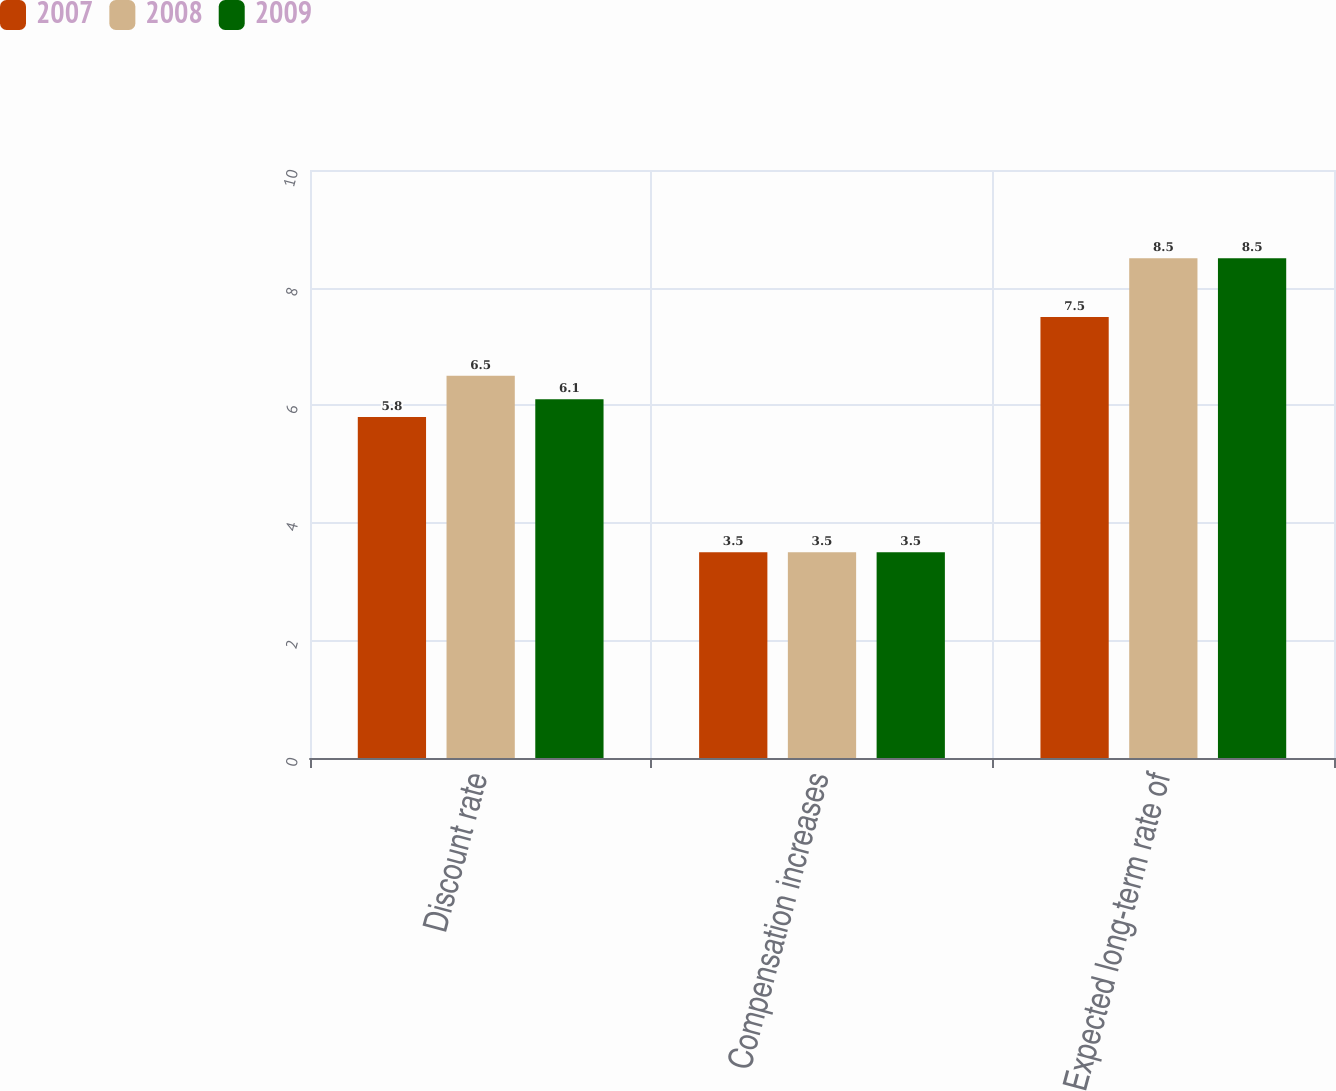Convert chart to OTSL. <chart><loc_0><loc_0><loc_500><loc_500><stacked_bar_chart><ecel><fcel>Discount rate<fcel>Compensation increases<fcel>Expected long-term rate of<nl><fcel>2007<fcel>5.8<fcel>3.5<fcel>7.5<nl><fcel>2008<fcel>6.5<fcel>3.5<fcel>8.5<nl><fcel>2009<fcel>6.1<fcel>3.5<fcel>8.5<nl></chart> 